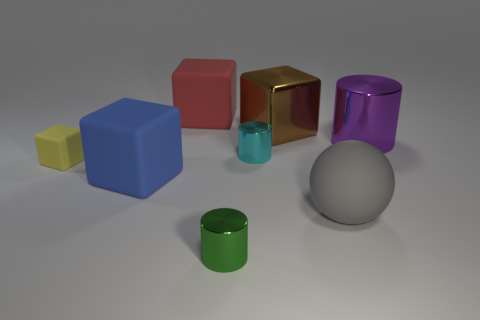What is the shape of the object that is in front of the ball?
Offer a terse response. Cylinder. How many rubber things are both behind the blue block and to the right of the brown cube?
Provide a short and direct response. 0. Is there a small ball made of the same material as the red object?
Offer a terse response. No. What number of cylinders are small cyan things or yellow rubber things?
Offer a very short reply. 1. How big is the green metallic cylinder?
Offer a very short reply. Small. What number of big gray things are on the right side of the brown block?
Offer a terse response. 1. There is a cube that is on the right side of the thing in front of the large gray object; how big is it?
Your answer should be very brief. Large. Does the large gray thing in front of the large purple metallic cylinder have the same shape as the big matte object that is behind the large brown shiny cube?
Your answer should be very brief. No. There is a small metallic object right of the tiny metal thing in front of the big gray thing; what shape is it?
Provide a succinct answer. Cylinder. What is the size of the object that is both to the right of the brown thing and in front of the large cylinder?
Your answer should be very brief. Large. 